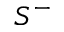Convert formula to latex. <formula><loc_0><loc_0><loc_500><loc_500>S ^ { - }</formula> 